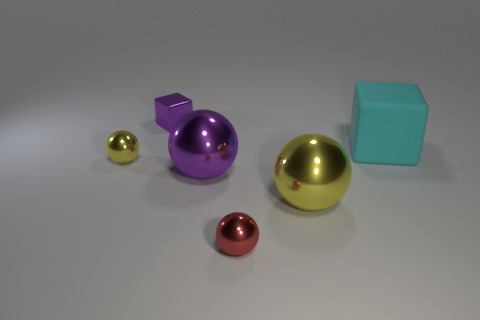Is there a pattern to the arrangement of the objects? There isn't an obvious intentional pattern, but visually, the objects are arranged by ascending size from left to right. 